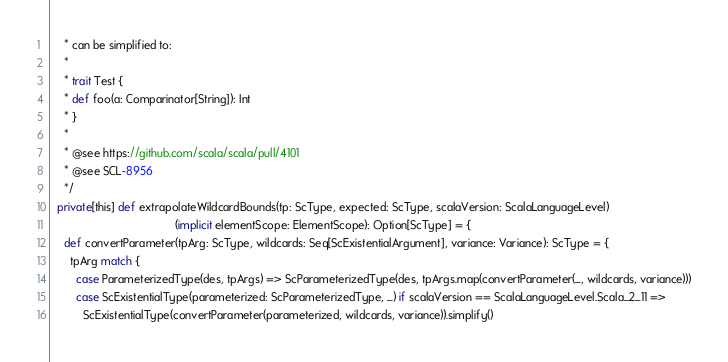<code> <loc_0><loc_0><loc_500><loc_500><_Scala_>    * can be simplified to:
    *
    * trait Test {
    * def foo(a: Comparinator[String]): Int
    * }
    *
    * @see https://github.com/scala/scala/pull/4101
    * @see SCL-8956
    */
  private[this] def extrapolateWildcardBounds(tp: ScType, expected: ScType, scalaVersion: ScalaLanguageLevel)
                                       (implicit elementScope: ElementScope): Option[ScType] = {
    def convertParameter(tpArg: ScType, wildcards: Seq[ScExistentialArgument], variance: Variance): ScType = {
      tpArg match {
        case ParameterizedType(des, tpArgs) => ScParameterizedType(des, tpArgs.map(convertParameter(_, wildcards, variance)))
        case ScExistentialType(parameterized: ScParameterizedType, _) if scalaVersion == ScalaLanguageLevel.Scala_2_11 =>
          ScExistentialType(convertParameter(parameterized, wildcards, variance)).simplify()</code> 